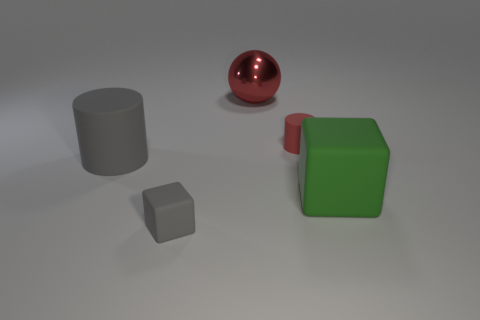Add 5 big gray rubber objects. How many objects exist? 10 Subtract all green cubes. How many cubes are left? 1 Subtract all cylinders. How many objects are left? 3 Subtract 0 purple cylinders. How many objects are left? 5 Subtract all brown cylinders. Subtract all blue balls. How many cylinders are left? 2 Subtract all matte balls. Subtract all rubber blocks. How many objects are left? 3 Add 1 green matte things. How many green matte things are left? 2 Add 3 small blue balls. How many small blue balls exist? 3 